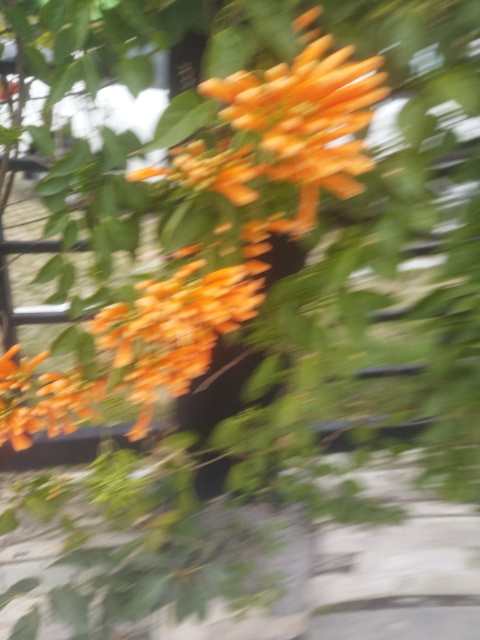What type of plant is visible in the photo? The plant in the photo appears to be a type of flowering vine, specifically it looks like a species of orange trumpet vines, known for their vibrant orange flowers. 